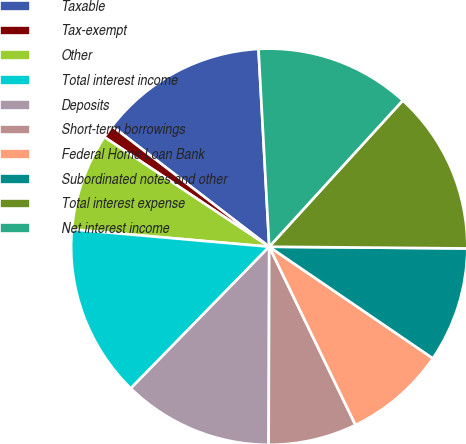Convert chart. <chart><loc_0><loc_0><loc_500><loc_500><pie_chart><fcel>Taxable<fcel>Tax-exempt<fcel>Other<fcel>Total interest income<fcel>Deposits<fcel>Short-term borrowings<fcel>Federal Home Loan Bank<fcel>Subordinated notes and other<fcel>Total interest expense<fcel>Net interest income<nl><fcel>13.72%<fcel>1.08%<fcel>7.94%<fcel>14.08%<fcel>12.27%<fcel>7.22%<fcel>8.3%<fcel>9.39%<fcel>13.36%<fcel>12.64%<nl></chart> 